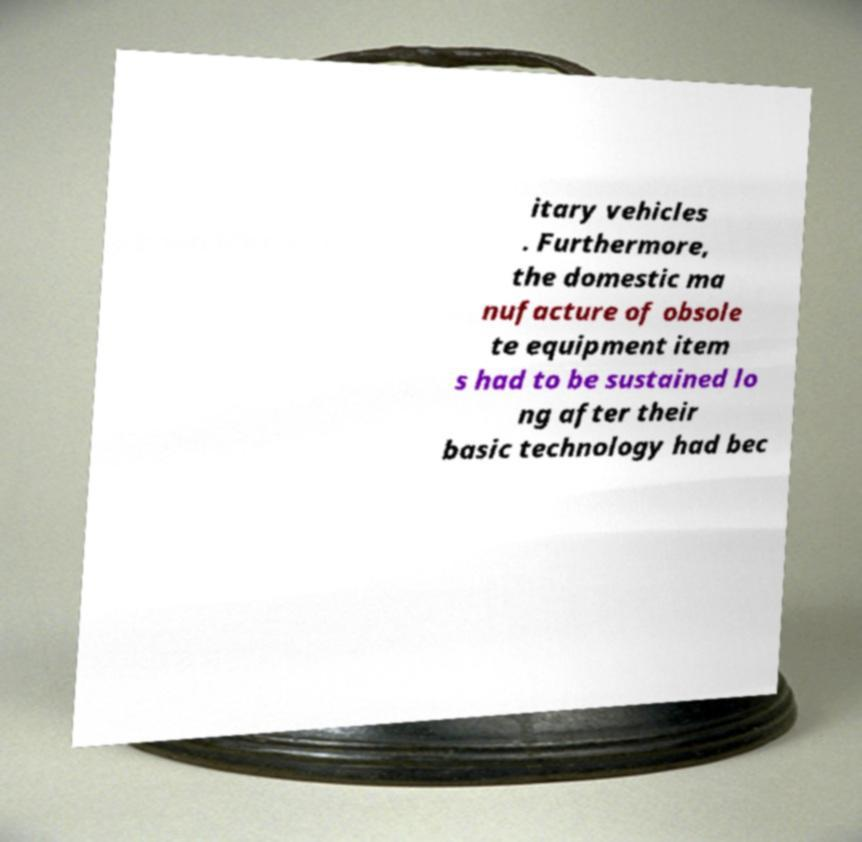There's text embedded in this image that I need extracted. Can you transcribe it verbatim? itary vehicles . Furthermore, the domestic ma nufacture of obsole te equipment item s had to be sustained lo ng after their basic technology had bec 